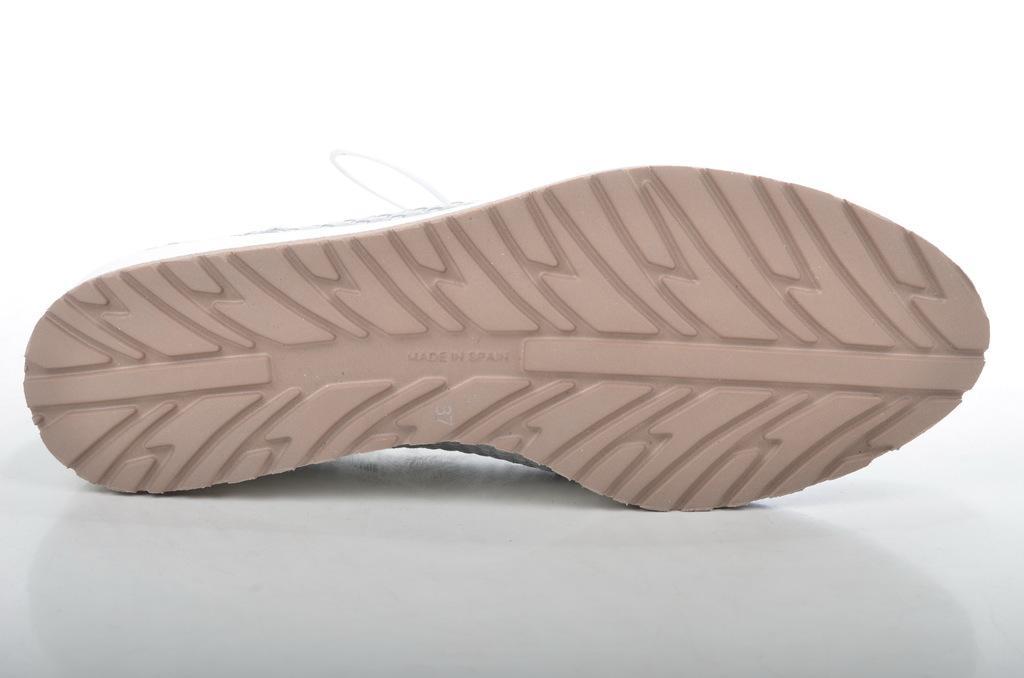Describe this image in one or two sentences. In this image we can see the footwear. 